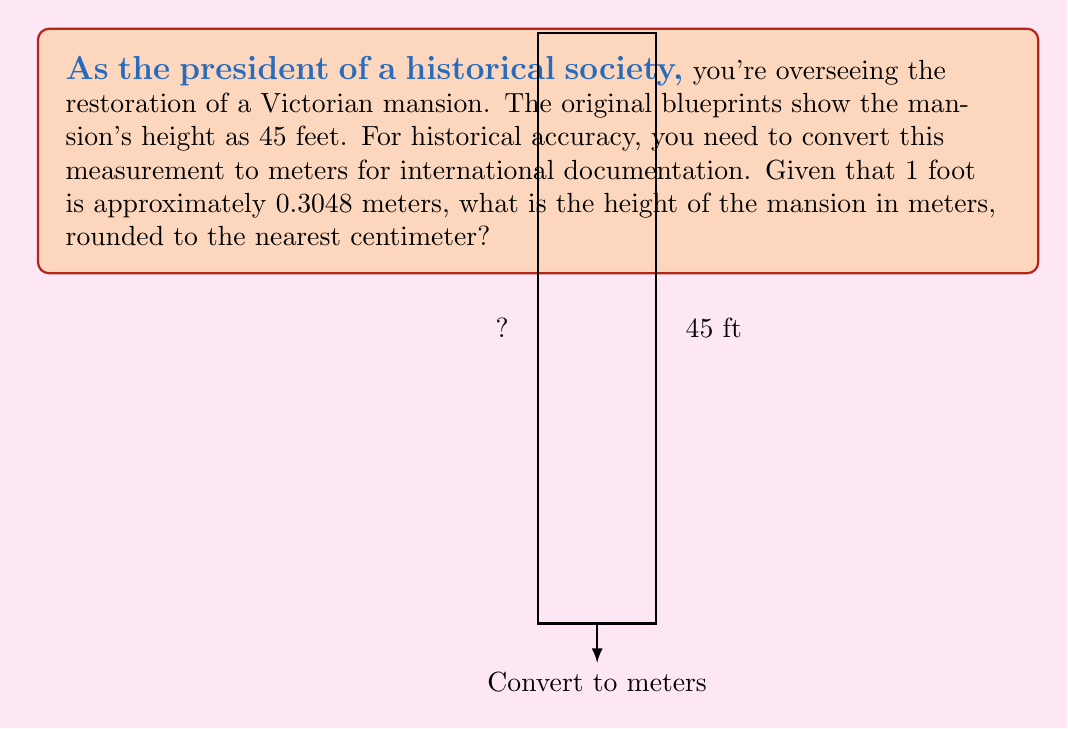What is the answer to this math problem? To convert the height from feet to meters, we'll use the given conversion factor:

1. Conversion factor: 1 foot = 0.3048 meters

2. Set up the conversion equation:
   $$ 45 \text{ feet} \times \frac{0.3048 \text{ meters}}{1 \text{ foot}} = x \text{ meters} $$

3. Multiply:
   $$ x = 45 \times 0.3048 = 13.716 \text{ meters} $$

4. Round to the nearest centimeter (2 decimal places):
   $$ 13.716 \text{ meters} \approx 13.72 \text{ meters} $$

Therefore, the height of the Victorian mansion is approximately 13.72 meters.
Answer: 13.72 m 